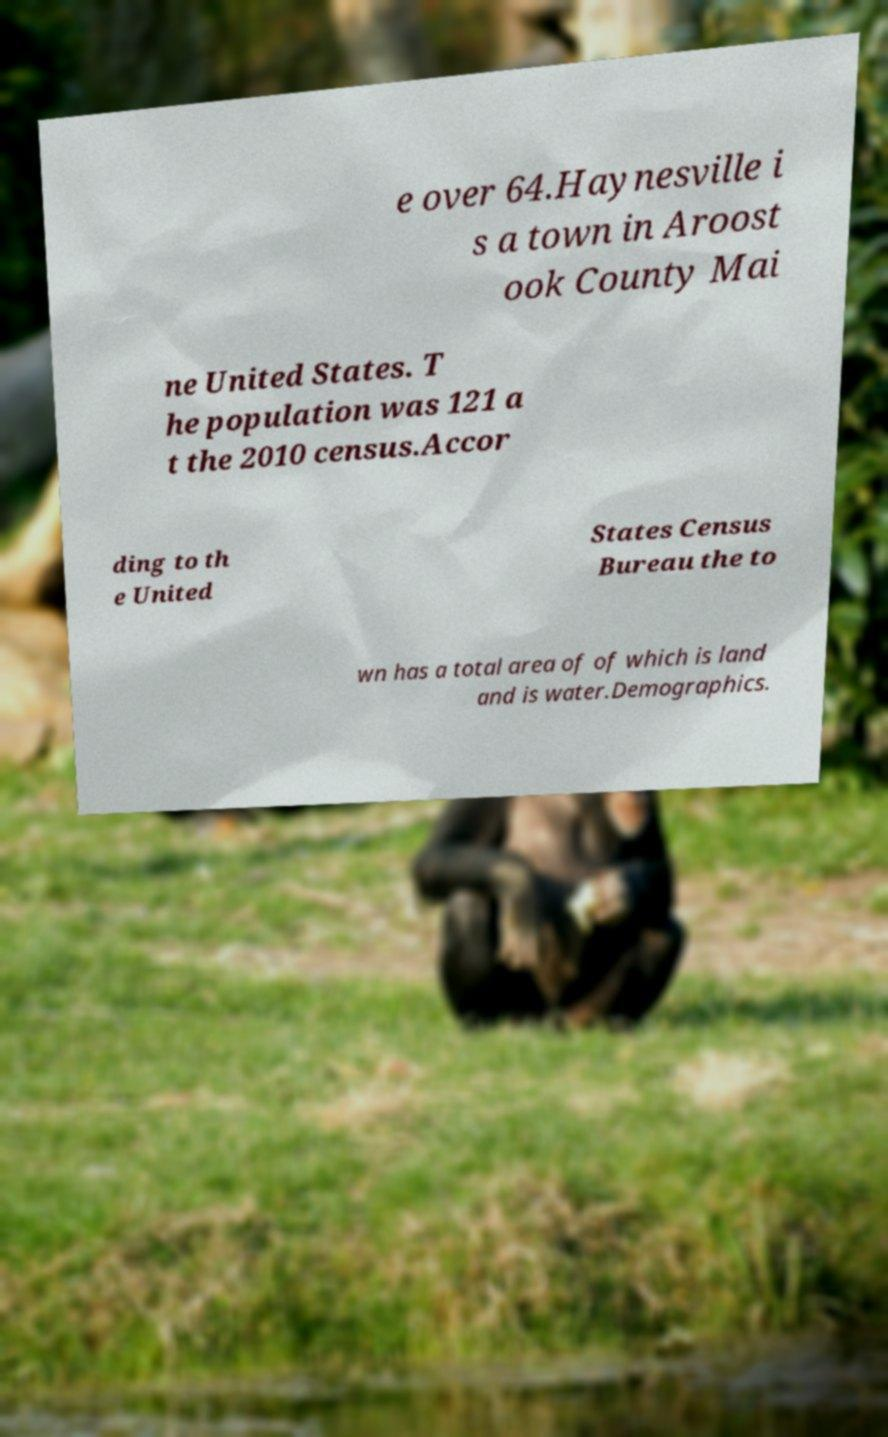For documentation purposes, I need the text within this image transcribed. Could you provide that? e over 64.Haynesville i s a town in Aroost ook County Mai ne United States. T he population was 121 a t the 2010 census.Accor ding to th e United States Census Bureau the to wn has a total area of of which is land and is water.Demographics. 